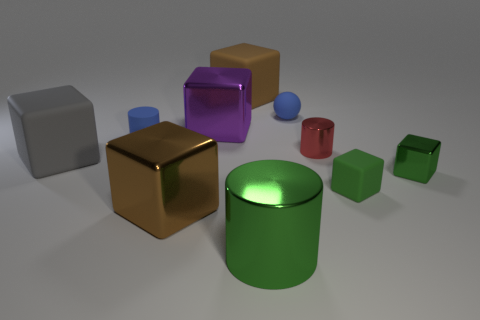What is the shape of the brown thing that is the same material as the large purple cube? cube 